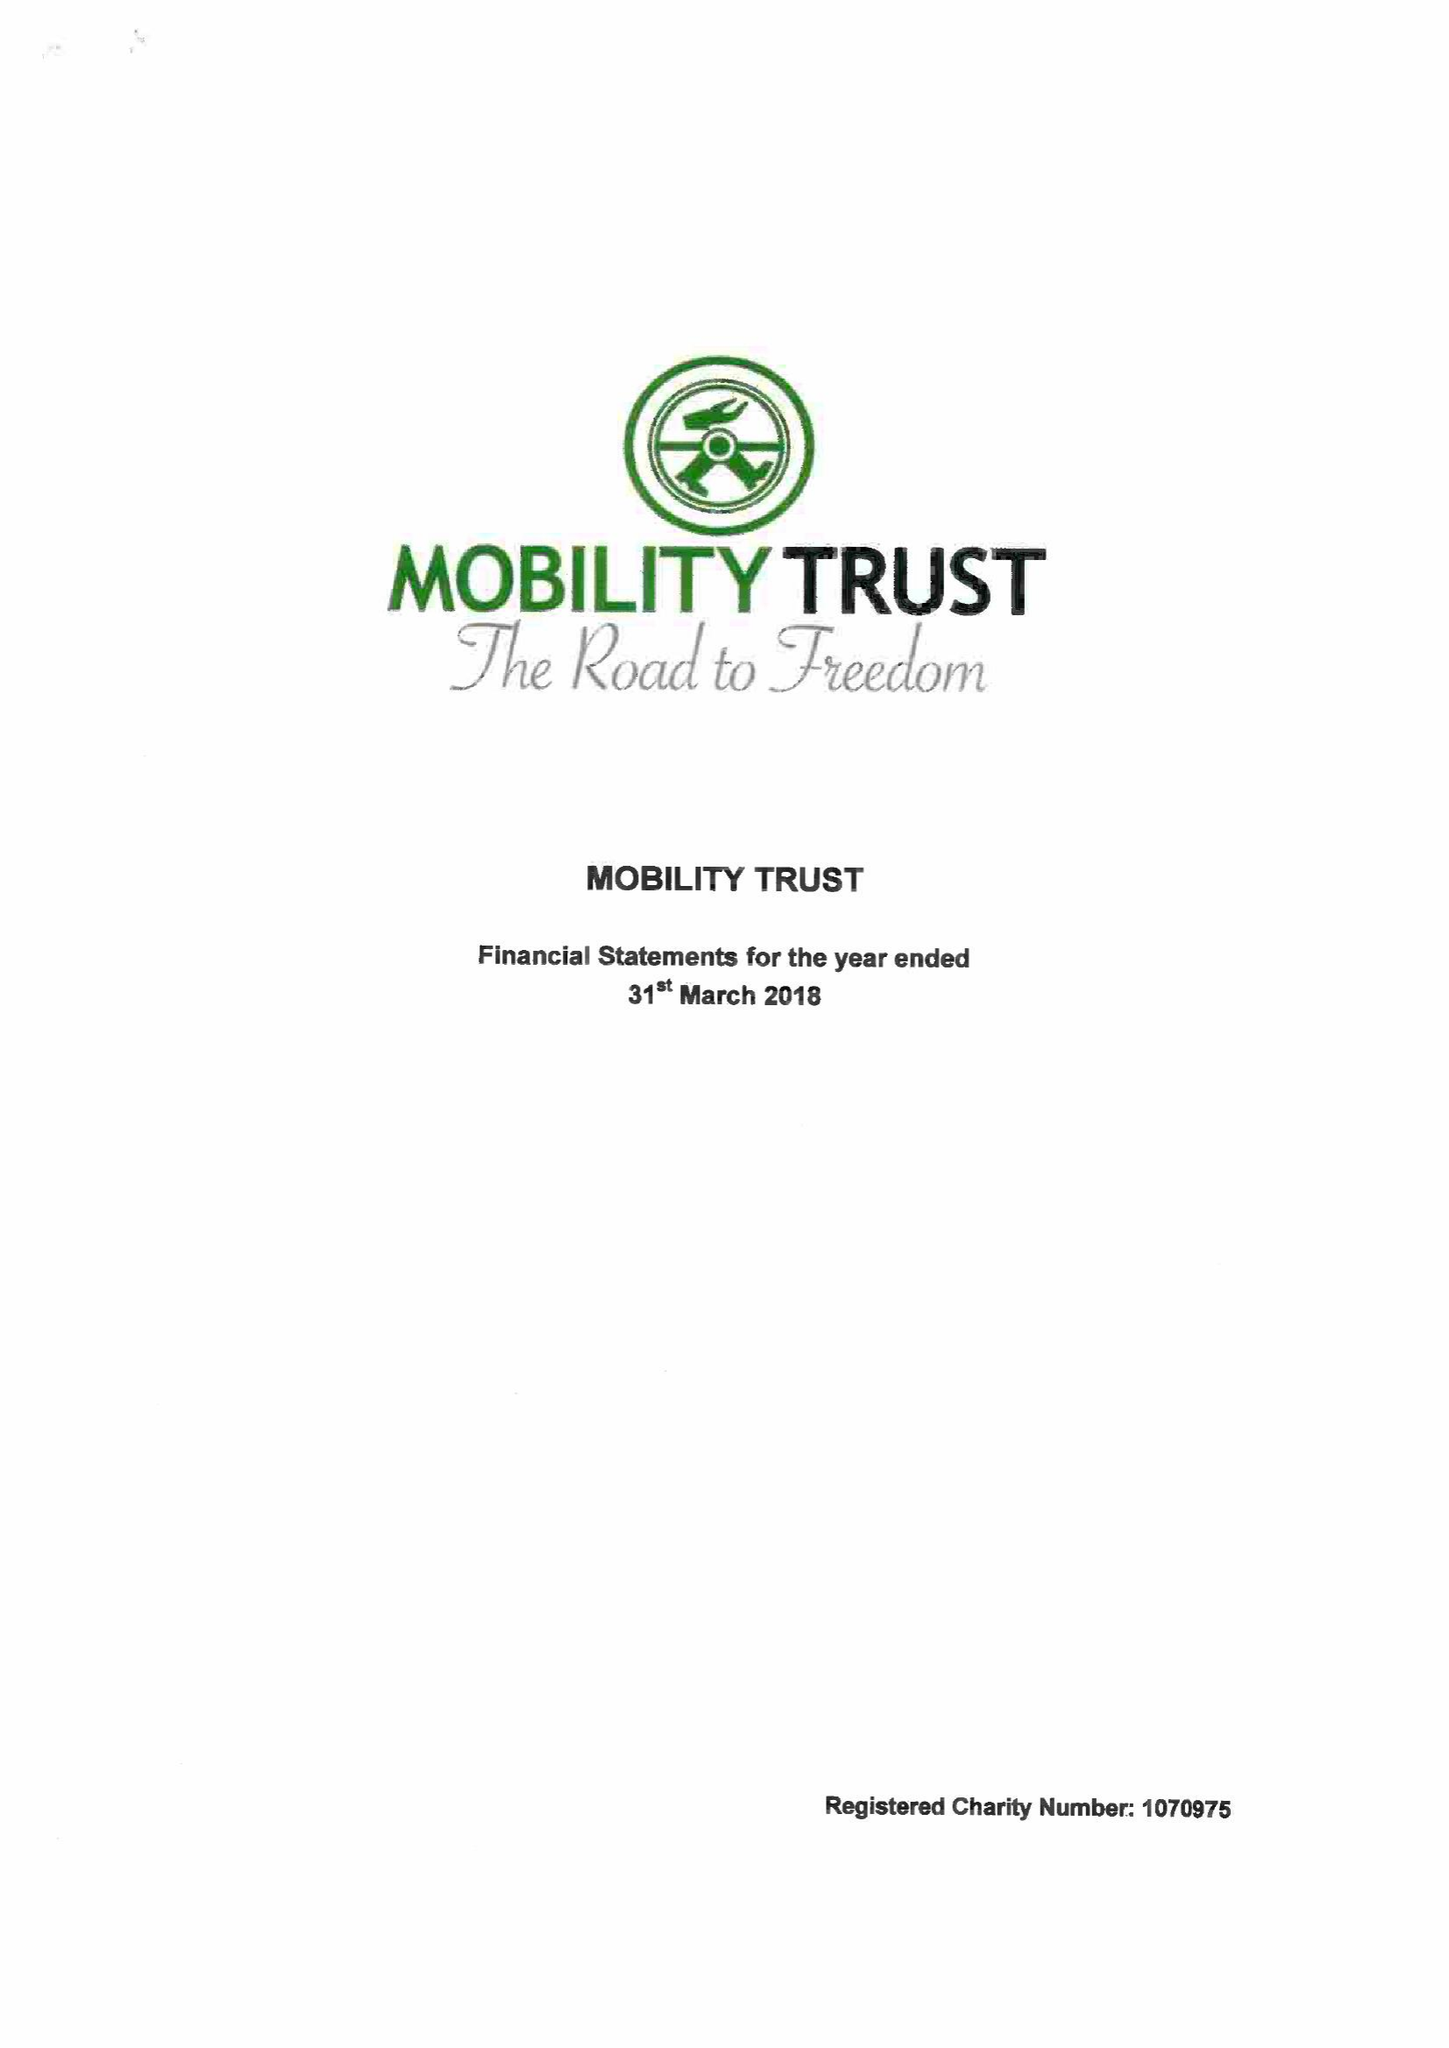What is the value for the address__street_line?
Answer the question using a single word or phrase. 19 READING ROAD 